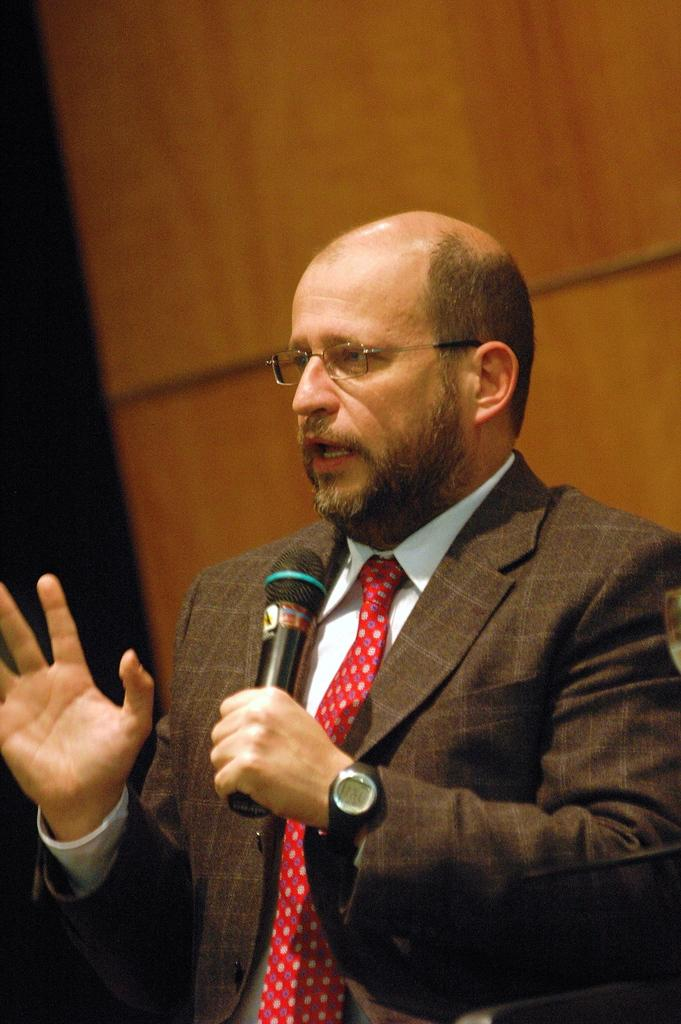What is the man in the image wearing? The man is wearing a suit and a red tie. What is the man doing in the image? The man is speaking in front of a microphone. What is the color of the background in the image? The background color is brown. How many trucks can be seen in the background of the image? There are no trucks visible in the image; the background color is brown. 